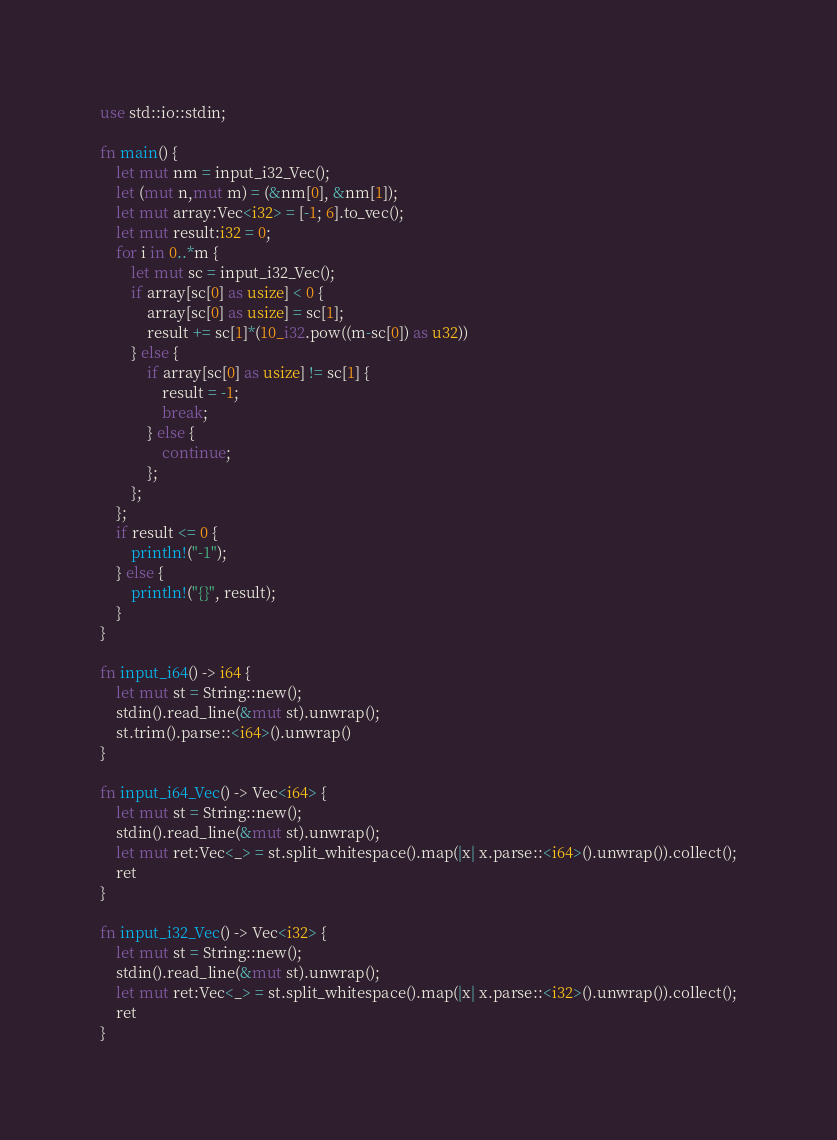Convert code to text. <code><loc_0><loc_0><loc_500><loc_500><_Rust_>use std::io::stdin;

fn main() {
    let mut nm = input_i32_Vec();
    let (mut n,mut m) = (&nm[0], &nm[1]);
    let mut array:Vec<i32> = [-1; 6].to_vec();
    let mut result:i32 = 0;
    for i in 0..*m {
        let mut sc = input_i32_Vec();
        if array[sc[0] as usize] < 0 {
            array[sc[0] as usize] = sc[1];
            result += sc[1]*(10_i32.pow((m-sc[0]) as u32))
        } else {
            if array[sc[0] as usize] != sc[1] {
                result = -1;
                break;
            } else {
                continue;
            };
        };
    };
    if result <= 0 {
        println!("-1");
    } else {
        println!("{}", result);
    }
}

fn input_i64() -> i64 {
    let mut st = String::new();
    stdin().read_line(&mut st).unwrap();
    st.trim().parse::<i64>().unwrap()
}

fn input_i64_Vec() -> Vec<i64> {
    let mut st = String::new();
    stdin().read_line(&mut st).unwrap();
    let mut ret:Vec<_> = st.split_whitespace().map(|x| x.parse::<i64>().unwrap()).collect();
    ret
}

fn input_i32_Vec() -> Vec<i32> {
    let mut st = String::new();
    stdin().read_line(&mut st).unwrap();
    let mut ret:Vec<_> = st.split_whitespace().map(|x| x.parse::<i32>().unwrap()).collect();
    ret
}</code> 